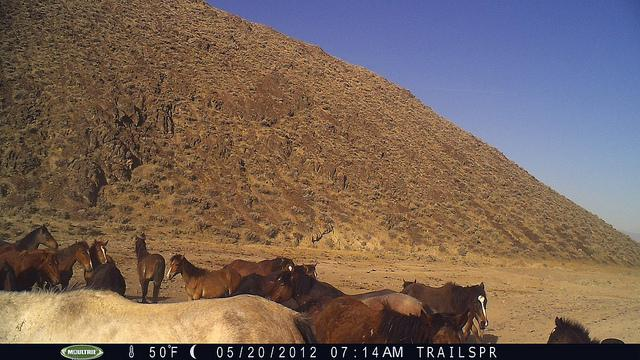What is the term used to call this group of horses?

Choices:
A) stampede
B) herd
C) wave
D) slide herd 